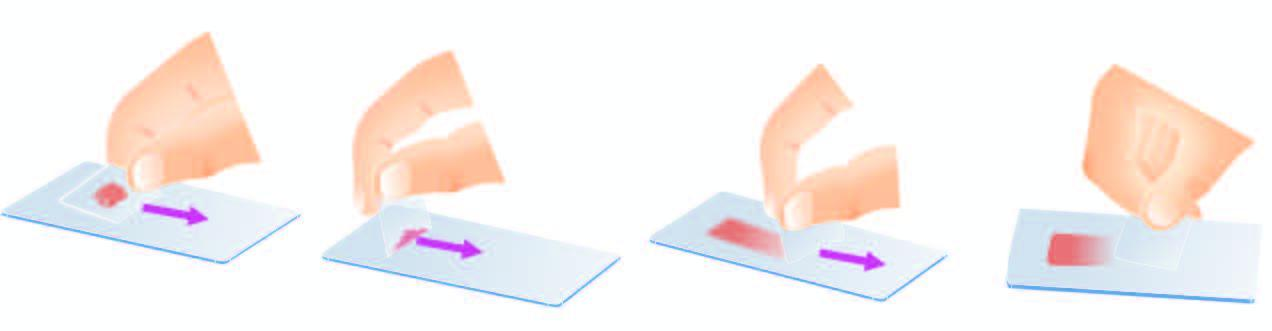what are crush-semisolid aspirates by?
Answer the question using a single word or phrase. Flat pressure with cover slip or glass slide 